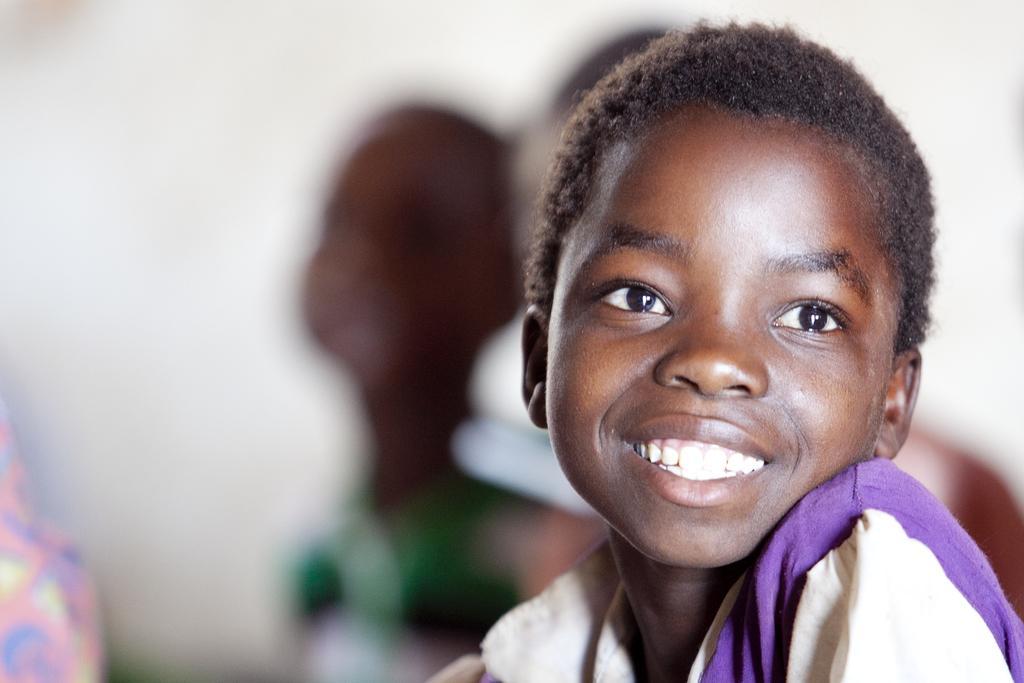How would you summarize this image in a sentence or two? In the picture we can see a small boy looking for a side and smiling and behind him we can see two more boys they are not clearly visible. 